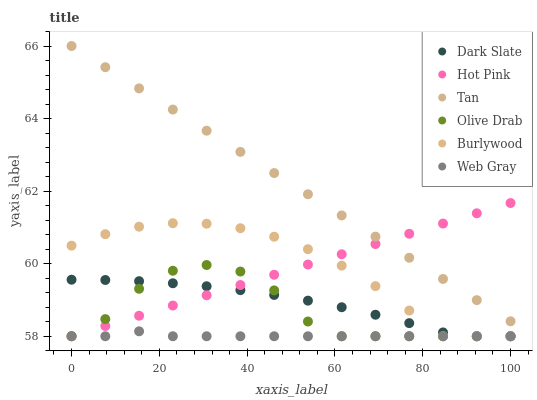Does Web Gray have the minimum area under the curve?
Answer yes or no. Yes. Does Tan have the maximum area under the curve?
Answer yes or no. Yes. Does Burlywood have the minimum area under the curve?
Answer yes or no. No. Does Burlywood have the maximum area under the curve?
Answer yes or no. No. Is Hot Pink the smoothest?
Answer yes or no. Yes. Is Olive Drab the roughest?
Answer yes or no. Yes. Is Burlywood the smoothest?
Answer yes or no. No. Is Burlywood the roughest?
Answer yes or no. No. Does Web Gray have the lowest value?
Answer yes or no. Yes. Does Tan have the lowest value?
Answer yes or no. No. Does Tan have the highest value?
Answer yes or no. Yes. Does Burlywood have the highest value?
Answer yes or no. No. Is Burlywood less than Tan?
Answer yes or no. Yes. Is Tan greater than Web Gray?
Answer yes or no. Yes. Does Dark Slate intersect Olive Drab?
Answer yes or no. Yes. Is Dark Slate less than Olive Drab?
Answer yes or no. No. Is Dark Slate greater than Olive Drab?
Answer yes or no. No. Does Burlywood intersect Tan?
Answer yes or no. No. 